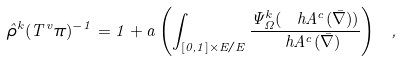Convert formula to latex. <formula><loc_0><loc_0><loc_500><loc_500>\hat { \rho } ^ { k } ( T ^ { v } \pi ) ^ { - 1 } = 1 + a \left ( \int _ { [ 0 , 1 ] \times E / E } \frac { \Psi ^ { k } _ { \Omega } ( \ h A ^ { c } ( \bar { \nabla } ) ) } { \ h A ^ { c } ( \bar { \nabla } ) } \right ) \ ,</formula> 